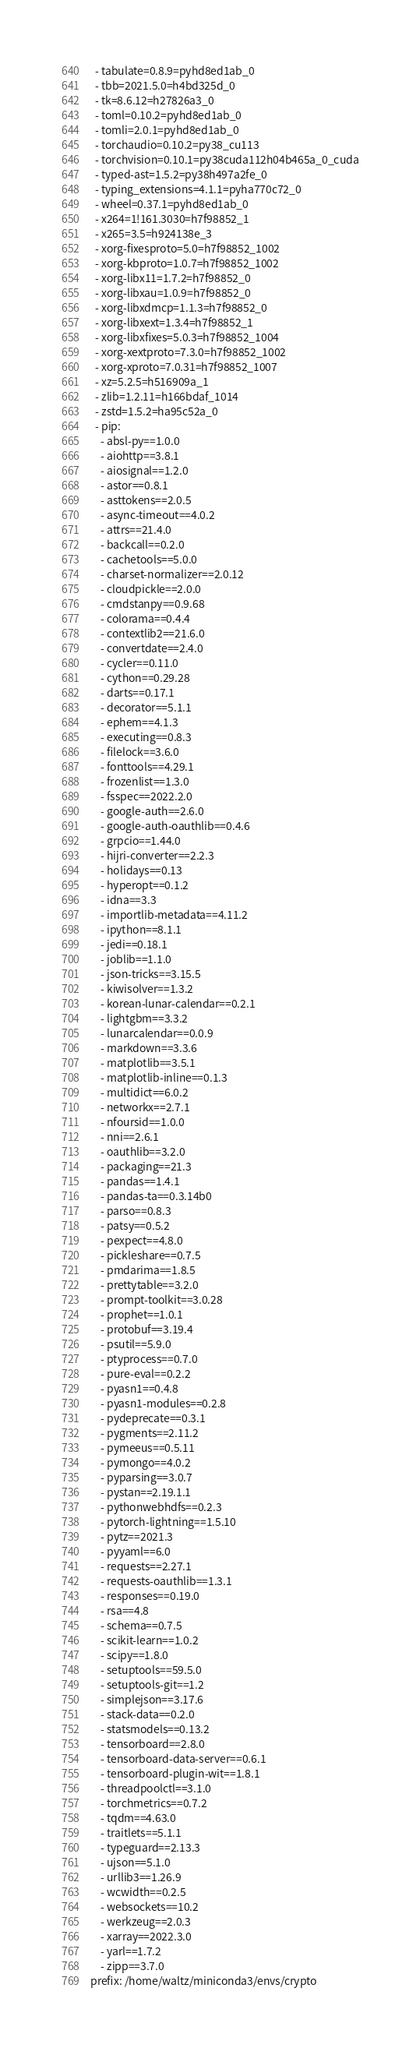<code> <loc_0><loc_0><loc_500><loc_500><_YAML_>  - tabulate=0.8.9=pyhd8ed1ab_0
  - tbb=2021.5.0=h4bd325d_0
  - tk=8.6.12=h27826a3_0
  - toml=0.10.2=pyhd8ed1ab_0
  - tomli=2.0.1=pyhd8ed1ab_0
  - torchaudio=0.10.2=py38_cu113
  - torchvision=0.10.1=py38cuda112h04b465a_0_cuda
  - typed-ast=1.5.2=py38h497a2fe_0
  - typing_extensions=4.1.1=pyha770c72_0
  - wheel=0.37.1=pyhd8ed1ab_0
  - x264=1!161.3030=h7f98852_1
  - x265=3.5=h924138e_3
  - xorg-fixesproto=5.0=h7f98852_1002
  - xorg-kbproto=1.0.7=h7f98852_1002
  - xorg-libx11=1.7.2=h7f98852_0
  - xorg-libxau=1.0.9=h7f98852_0
  - xorg-libxdmcp=1.1.3=h7f98852_0
  - xorg-libxext=1.3.4=h7f98852_1
  - xorg-libxfixes=5.0.3=h7f98852_1004
  - xorg-xextproto=7.3.0=h7f98852_1002
  - xorg-xproto=7.0.31=h7f98852_1007
  - xz=5.2.5=h516909a_1
  - zlib=1.2.11=h166bdaf_1014
  - zstd=1.5.2=ha95c52a_0
  - pip:
    - absl-py==1.0.0
    - aiohttp==3.8.1
    - aiosignal==1.2.0
    - astor==0.8.1
    - asttokens==2.0.5
    - async-timeout==4.0.2
    - attrs==21.4.0
    - backcall==0.2.0
    - cachetools==5.0.0
    - charset-normalizer==2.0.12
    - cloudpickle==2.0.0
    - cmdstanpy==0.9.68
    - colorama==0.4.4
    - contextlib2==21.6.0
    - convertdate==2.4.0
    - cycler==0.11.0
    - cython==0.29.28
    - darts==0.17.1
    - decorator==5.1.1
    - ephem==4.1.3
    - executing==0.8.3
    - filelock==3.6.0
    - fonttools==4.29.1
    - frozenlist==1.3.0
    - fsspec==2022.2.0
    - google-auth==2.6.0
    - google-auth-oauthlib==0.4.6
    - grpcio==1.44.0
    - hijri-converter==2.2.3
    - holidays==0.13
    - hyperopt==0.1.2
    - idna==3.3
    - importlib-metadata==4.11.2
    - ipython==8.1.1
    - jedi==0.18.1
    - joblib==1.1.0
    - json-tricks==3.15.5
    - kiwisolver==1.3.2
    - korean-lunar-calendar==0.2.1
    - lightgbm==3.3.2
    - lunarcalendar==0.0.9
    - markdown==3.3.6
    - matplotlib==3.5.1
    - matplotlib-inline==0.1.3
    - multidict==6.0.2
    - networkx==2.7.1
    - nfoursid==1.0.0
    - nni==2.6.1
    - oauthlib==3.2.0
    - packaging==21.3
    - pandas==1.4.1
    - pandas-ta==0.3.14b0
    - parso==0.8.3
    - patsy==0.5.2
    - pexpect==4.8.0
    - pickleshare==0.7.5
    - pmdarima==1.8.5
    - prettytable==3.2.0
    - prompt-toolkit==3.0.28
    - prophet==1.0.1
    - protobuf==3.19.4
    - psutil==5.9.0
    - ptyprocess==0.7.0
    - pure-eval==0.2.2
    - pyasn1==0.4.8
    - pyasn1-modules==0.2.8
    - pydeprecate==0.3.1
    - pygments==2.11.2
    - pymeeus==0.5.11
    - pymongo==4.0.2
    - pyparsing==3.0.7
    - pystan==2.19.1.1
    - pythonwebhdfs==0.2.3
    - pytorch-lightning==1.5.10
    - pytz==2021.3
    - pyyaml==6.0
    - requests==2.27.1
    - requests-oauthlib==1.3.1
    - responses==0.19.0
    - rsa==4.8
    - schema==0.7.5
    - scikit-learn==1.0.2
    - scipy==1.8.0
    - setuptools==59.5.0
    - setuptools-git==1.2
    - simplejson==3.17.6
    - stack-data==0.2.0
    - statsmodels==0.13.2
    - tensorboard==2.8.0
    - tensorboard-data-server==0.6.1
    - tensorboard-plugin-wit==1.8.1
    - threadpoolctl==3.1.0
    - torchmetrics==0.7.2
    - tqdm==4.63.0
    - traitlets==5.1.1
    - typeguard==2.13.3
    - ujson==5.1.0
    - urllib3==1.26.9
    - wcwidth==0.2.5
    - websockets==10.2
    - werkzeug==2.0.3
    - xarray==2022.3.0
    - yarl==1.7.2
    - zipp==3.7.0
prefix: /home/waltz/miniconda3/envs/crypto
</code> 